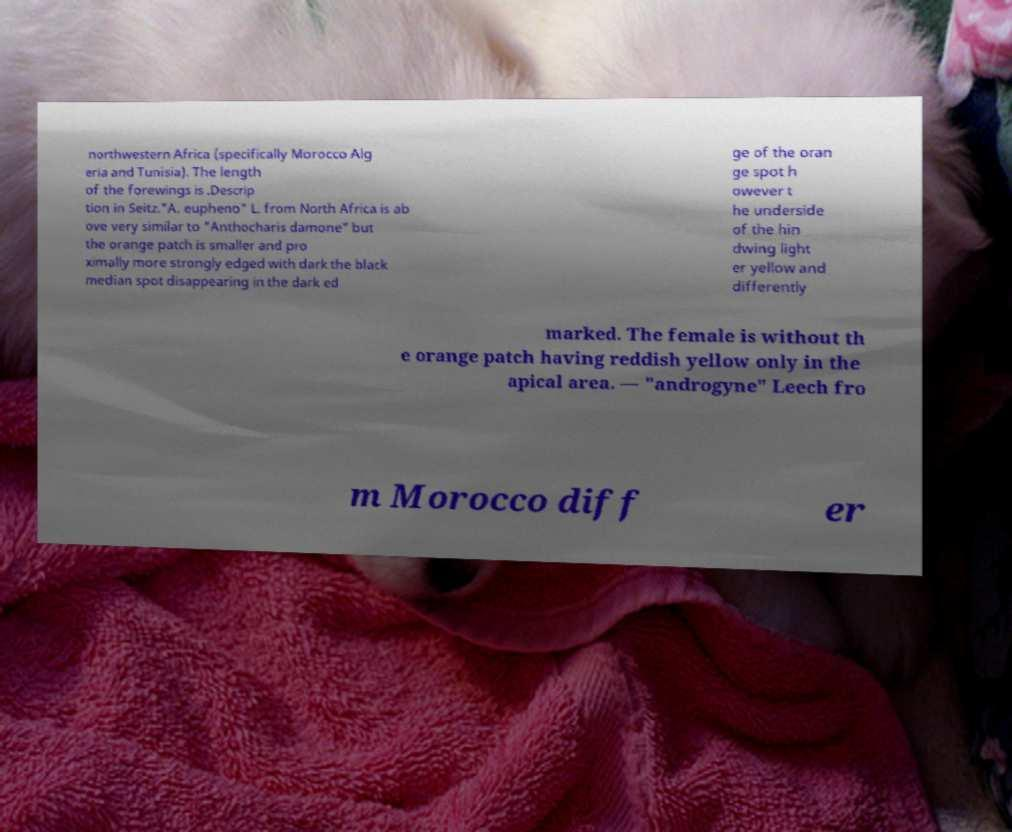Please read and relay the text visible in this image. What does it say? northwestern Africa (specifically Morocco Alg eria and Tunisia). The length of the forewings is .Descrip tion in Seitz."A. eupheno" L. from North Africa is ab ove very similar to "Anthocharis damone" but the orange patch is smaller and pro ximally more strongly edged with dark the black median spot disappearing in the dark ed ge of the oran ge spot h owever t he underside of the hin dwing light er yellow and differently marked. The female is without th e orange patch having reddish yellow only in the apical area. — "androgyne" Leech fro m Morocco diff er 